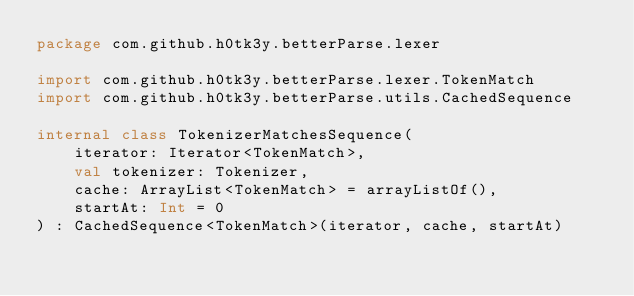<code> <loc_0><loc_0><loc_500><loc_500><_Kotlin_>package com.github.h0tk3y.betterParse.lexer

import com.github.h0tk3y.betterParse.lexer.TokenMatch
import com.github.h0tk3y.betterParse.utils.CachedSequence

internal class TokenizerMatchesSequence(
    iterator: Iterator<TokenMatch>,
    val tokenizer: Tokenizer,
    cache: ArrayList<TokenMatch> = arrayListOf(),
    startAt: Int = 0
) : CachedSequence<TokenMatch>(iterator, cache, startAt)</code> 